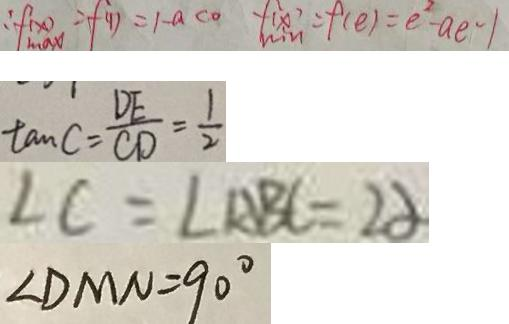<formula> <loc_0><loc_0><loc_500><loc_500>\therefore f _ { \max } ( x ) = f ( 1 ) = 1 - a < 0 f _ { \min } ( x ) = f ( e ) = e ^ { 2 } - a e - 1 
 \tan C = \frac { D E } { C D } = \frac { 1 } { 2 } 
 \angle C = \angle A B C = 2 \alpha 
 \angle D M N = 9 0 ^ { \circ }</formula> 